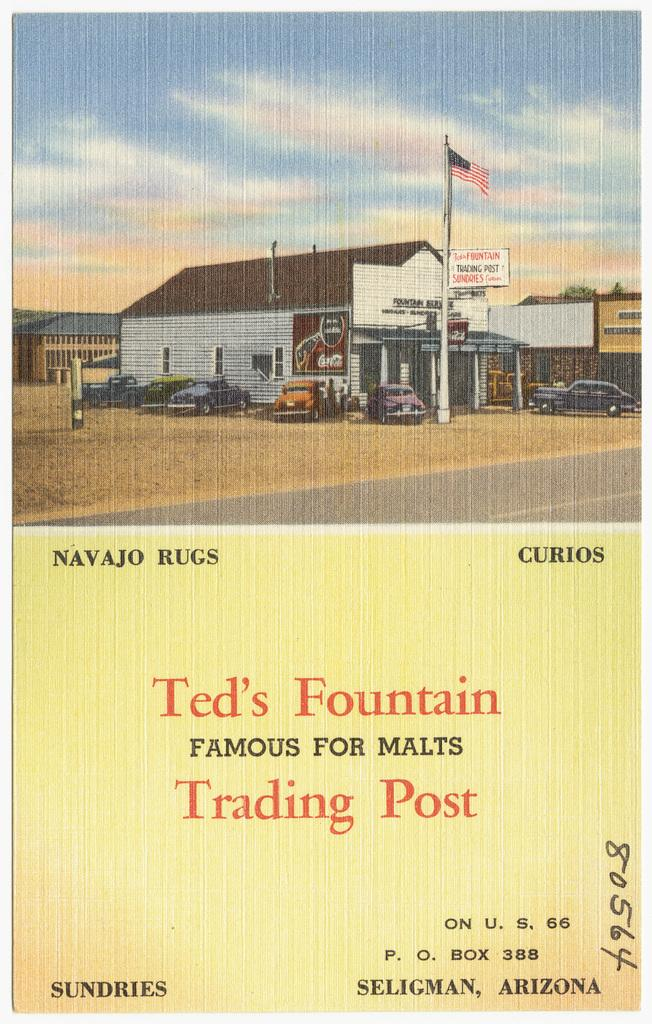Provide a one-sentence caption for the provided image. An old advertisement shows a picture of Ted's Fountain Trading Post in Seligman, Arizona. 